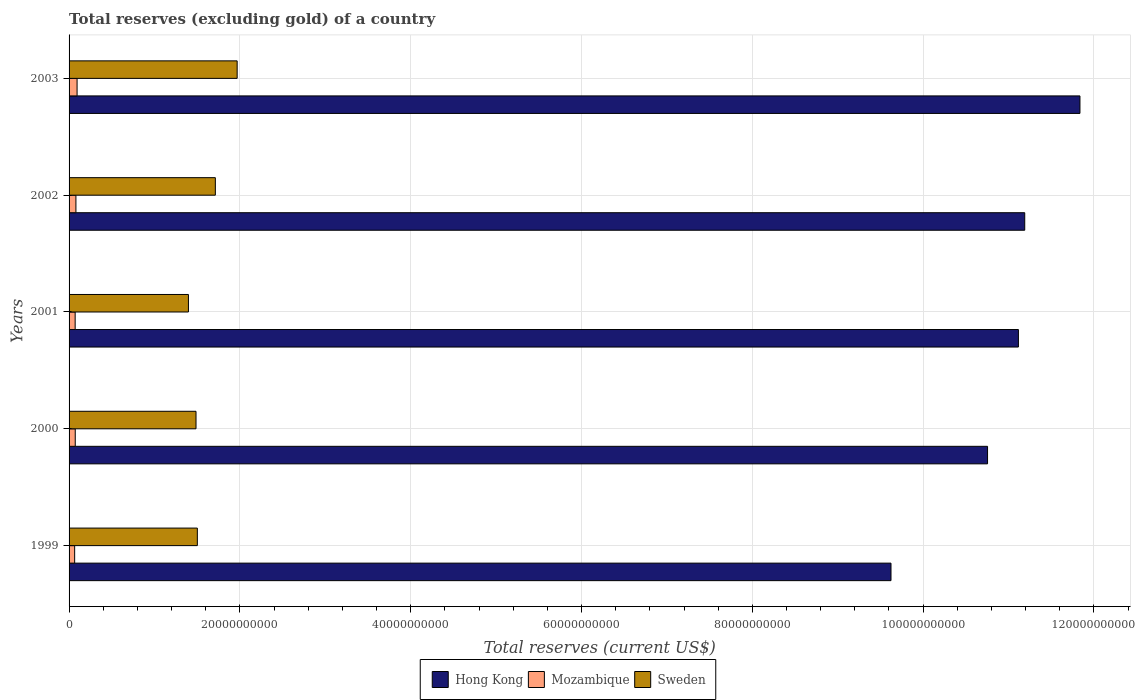How many groups of bars are there?
Offer a very short reply. 5. Are the number of bars per tick equal to the number of legend labels?
Give a very brief answer. Yes. Are the number of bars on each tick of the Y-axis equal?
Provide a short and direct response. Yes. What is the label of the 2nd group of bars from the top?
Your response must be concise. 2002. In how many cases, is the number of bars for a given year not equal to the number of legend labels?
Provide a succinct answer. 0. What is the total reserves (excluding gold) in Mozambique in 2002?
Keep it short and to the point. 8.02e+08. Across all years, what is the maximum total reserves (excluding gold) in Hong Kong?
Provide a succinct answer. 1.18e+11. Across all years, what is the minimum total reserves (excluding gold) in Mozambique?
Ensure brevity in your answer.  6.54e+08. In which year was the total reserves (excluding gold) in Mozambique minimum?
Provide a short and direct response. 1999. What is the total total reserves (excluding gold) in Sweden in the graph?
Your response must be concise. 8.07e+1. What is the difference between the total reserves (excluding gold) in Mozambique in 2000 and that in 2003?
Give a very brief answer. -2.14e+08. What is the difference between the total reserves (excluding gold) in Mozambique in 2001 and the total reserves (excluding gold) in Hong Kong in 2003?
Your answer should be compact. -1.18e+11. What is the average total reserves (excluding gold) in Hong Kong per year?
Make the answer very short. 1.09e+11. In the year 1999, what is the difference between the total reserves (excluding gold) in Mozambique and total reserves (excluding gold) in Hong Kong?
Your response must be concise. -9.56e+1. What is the ratio of the total reserves (excluding gold) in Mozambique in 2001 to that in 2002?
Make the answer very short. 0.89. Is the total reserves (excluding gold) in Mozambique in 1999 less than that in 2002?
Offer a terse response. Yes. What is the difference between the highest and the second highest total reserves (excluding gold) in Sweden?
Provide a short and direct response. 2.55e+09. What is the difference between the highest and the lowest total reserves (excluding gold) in Mozambique?
Your answer should be compact. 2.83e+08. In how many years, is the total reserves (excluding gold) in Hong Kong greater than the average total reserves (excluding gold) in Hong Kong taken over all years?
Offer a very short reply. 3. Is the sum of the total reserves (excluding gold) in Sweden in 2001 and 2003 greater than the maximum total reserves (excluding gold) in Hong Kong across all years?
Your answer should be very brief. No. What does the 3rd bar from the bottom in 2001 represents?
Make the answer very short. Sweden. Is it the case that in every year, the sum of the total reserves (excluding gold) in Mozambique and total reserves (excluding gold) in Hong Kong is greater than the total reserves (excluding gold) in Sweden?
Ensure brevity in your answer.  Yes. How many bars are there?
Give a very brief answer. 15. Are all the bars in the graph horizontal?
Keep it short and to the point. Yes. Does the graph contain grids?
Keep it short and to the point. Yes. What is the title of the graph?
Keep it short and to the point. Total reserves (excluding gold) of a country. Does "Fiji" appear as one of the legend labels in the graph?
Make the answer very short. No. What is the label or title of the X-axis?
Offer a terse response. Total reserves (current US$). What is the Total reserves (current US$) in Hong Kong in 1999?
Your response must be concise. 9.62e+1. What is the Total reserves (current US$) in Mozambique in 1999?
Your answer should be very brief. 6.54e+08. What is the Total reserves (current US$) of Sweden in 1999?
Keep it short and to the point. 1.50e+1. What is the Total reserves (current US$) in Hong Kong in 2000?
Provide a succinct answer. 1.08e+11. What is the Total reserves (current US$) in Mozambique in 2000?
Your response must be concise. 7.23e+08. What is the Total reserves (current US$) in Sweden in 2000?
Offer a terse response. 1.49e+1. What is the Total reserves (current US$) of Hong Kong in 2001?
Provide a succinct answer. 1.11e+11. What is the Total reserves (current US$) in Mozambique in 2001?
Offer a terse response. 7.13e+08. What is the Total reserves (current US$) in Sweden in 2001?
Give a very brief answer. 1.40e+1. What is the Total reserves (current US$) in Hong Kong in 2002?
Your answer should be compact. 1.12e+11. What is the Total reserves (current US$) of Mozambique in 2002?
Ensure brevity in your answer.  8.02e+08. What is the Total reserves (current US$) in Sweden in 2002?
Offer a terse response. 1.71e+1. What is the Total reserves (current US$) of Hong Kong in 2003?
Your answer should be very brief. 1.18e+11. What is the Total reserves (current US$) in Mozambique in 2003?
Offer a terse response. 9.37e+08. What is the Total reserves (current US$) in Sweden in 2003?
Your answer should be very brief. 1.97e+1. Across all years, what is the maximum Total reserves (current US$) of Hong Kong?
Your answer should be very brief. 1.18e+11. Across all years, what is the maximum Total reserves (current US$) of Mozambique?
Provide a short and direct response. 9.37e+08. Across all years, what is the maximum Total reserves (current US$) of Sweden?
Keep it short and to the point. 1.97e+1. Across all years, what is the minimum Total reserves (current US$) of Hong Kong?
Ensure brevity in your answer.  9.62e+1. Across all years, what is the minimum Total reserves (current US$) in Mozambique?
Your answer should be compact. 6.54e+08. Across all years, what is the minimum Total reserves (current US$) of Sweden?
Make the answer very short. 1.40e+1. What is the total Total reserves (current US$) of Hong Kong in the graph?
Provide a succinct answer. 5.45e+11. What is the total Total reserves (current US$) of Mozambique in the graph?
Make the answer very short. 3.83e+09. What is the total Total reserves (current US$) of Sweden in the graph?
Your answer should be compact. 8.07e+1. What is the difference between the Total reserves (current US$) in Hong Kong in 1999 and that in 2000?
Give a very brief answer. -1.13e+1. What is the difference between the Total reserves (current US$) in Mozambique in 1999 and that in 2000?
Your answer should be very brief. -6.92e+07. What is the difference between the Total reserves (current US$) in Sweden in 1999 and that in 2000?
Your answer should be very brief. 1.56e+08. What is the difference between the Total reserves (current US$) of Hong Kong in 1999 and that in 2001?
Your answer should be compact. -1.49e+1. What is the difference between the Total reserves (current US$) of Mozambique in 1999 and that in 2001?
Provide a short and direct response. -5.92e+07. What is the difference between the Total reserves (current US$) of Sweden in 1999 and that in 2001?
Your answer should be very brief. 1.04e+09. What is the difference between the Total reserves (current US$) of Hong Kong in 1999 and that in 2002?
Your answer should be very brief. -1.57e+1. What is the difference between the Total reserves (current US$) of Mozambique in 1999 and that in 2002?
Your answer should be compact. -1.48e+08. What is the difference between the Total reserves (current US$) of Sweden in 1999 and that in 2002?
Your answer should be very brief. -2.11e+09. What is the difference between the Total reserves (current US$) of Hong Kong in 1999 and that in 2003?
Make the answer very short. -2.21e+1. What is the difference between the Total reserves (current US$) of Mozambique in 1999 and that in 2003?
Provide a succinct answer. -2.83e+08. What is the difference between the Total reserves (current US$) in Sweden in 1999 and that in 2003?
Make the answer very short. -4.66e+09. What is the difference between the Total reserves (current US$) of Hong Kong in 2000 and that in 2001?
Offer a very short reply. -3.61e+09. What is the difference between the Total reserves (current US$) of Mozambique in 2000 and that in 2001?
Give a very brief answer. 9.96e+06. What is the difference between the Total reserves (current US$) of Sweden in 2000 and that in 2001?
Provide a succinct answer. 8.86e+08. What is the difference between the Total reserves (current US$) in Hong Kong in 2000 and that in 2002?
Give a very brief answer. -4.35e+09. What is the difference between the Total reserves (current US$) in Mozambique in 2000 and that in 2002?
Keep it short and to the point. -7.93e+07. What is the difference between the Total reserves (current US$) of Sweden in 2000 and that in 2002?
Provide a succinct answer. -2.26e+09. What is the difference between the Total reserves (current US$) of Hong Kong in 2000 and that in 2003?
Make the answer very short. -1.08e+1. What is the difference between the Total reserves (current US$) of Mozambique in 2000 and that in 2003?
Give a very brief answer. -2.14e+08. What is the difference between the Total reserves (current US$) in Sweden in 2000 and that in 2003?
Your answer should be very brief. -4.82e+09. What is the difference between the Total reserves (current US$) of Hong Kong in 2001 and that in 2002?
Make the answer very short. -7.41e+08. What is the difference between the Total reserves (current US$) of Mozambique in 2001 and that in 2002?
Give a very brief answer. -8.93e+07. What is the difference between the Total reserves (current US$) in Sweden in 2001 and that in 2002?
Offer a very short reply. -3.15e+09. What is the difference between the Total reserves (current US$) of Hong Kong in 2001 and that in 2003?
Your answer should be compact. -7.21e+09. What is the difference between the Total reserves (current US$) of Mozambique in 2001 and that in 2003?
Offer a terse response. -2.24e+08. What is the difference between the Total reserves (current US$) in Sweden in 2001 and that in 2003?
Provide a short and direct response. -5.70e+09. What is the difference between the Total reserves (current US$) of Hong Kong in 2002 and that in 2003?
Your answer should be compact. -6.46e+09. What is the difference between the Total reserves (current US$) of Mozambique in 2002 and that in 2003?
Keep it short and to the point. -1.35e+08. What is the difference between the Total reserves (current US$) of Sweden in 2002 and that in 2003?
Provide a succinct answer. -2.55e+09. What is the difference between the Total reserves (current US$) in Hong Kong in 1999 and the Total reserves (current US$) in Mozambique in 2000?
Provide a short and direct response. 9.55e+1. What is the difference between the Total reserves (current US$) in Hong Kong in 1999 and the Total reserves (current US$) in Sweden in 2000?
Offer a very short reply. 8.14e+1. What is the difference between the Total reserves (current US$) in Mozambique in 1999 and the Total reserves (current US$) in Sweden in 2000?
Ensure brevity in your answer.  -1.42e+1. What is the difference between the Total reserves (current US$) in Hong Kong in 1999 and the Total reserves (current US$) in Mozambique in 2001?
Keep it short and to the point. 9.55e+1. What is the difference between the Total reserves (current US$) of Hong Kong in 1999 and the Total reserves (current US$) of Sweden in 2001?
Give a very brief answer. 8.23e+1. What is the difference between the Total reserves (current US$) of Mozambique in 1999 and the Total reserves (current US$) of Sweden in 2001?
Keep it short and to the point. -1.33e+1. What is the difference between the Total reserves (current US$) of Hong Kong in 1999 and the Total reserves (current US$) of Mozambique in 2002?
Your response must be concise. 9.54e+1. What is the difference between the Total reserves (current US$) in Hong Kong in 1999 and the Total reserves (current US$) in Sweden in 2002?
Make the answer very short. 7.91e+1. What is the difference between the Total reserves (current US$) in Mozambique in 1999 and the Total reserves (current US$) in Sweden in 2002?
Keep it short and to the point. -1.65e+1. What is the difference between the Total reserves (current US$) of Hong Kong in 1999 and the Total reserves (current US$) of Mozambique in 2003?
Give a very brief answer. 9.53e+1. What is the difference between the Total reserves (current US$) of Hong Kong in 1999 and the Total reserves (current US$) of Sweden in 2003?
Make the answer very short. 7.66e+1. What is the difference between the Total reserves (current US$) of Mozambique in 1999 and the Total reserves (current US$) of Sweden in 2003?
Provide a succinct answer. -1.90e+1. What is the difference between the Total reserves (current US$) in Hong Kong in 2000 and the Total reserves (current US$) in Mozambique in 2001?
Give a very brief answer. 1.07e+11. What is the difference between the Total reserves (current US$) of Hong Kong in 2000 and the Total reserves (current US$) of Sweden in 2001?
Your answer should be compact. 9.36e+1. What is the difference between the Total reserves (current US$) of Mozambique in 2000 and the Total reserves (current US$) of Sweden in 2001?
Your answer should be compact. -1.33e+1. What is the difference between the Total reserves (current US$) of Hong Kong in 2000 and the Total reserves (current US$) of Mozambique in 2002?
Your response must be concise. 1.07e+11. What is the difference between the Total reserves (current US$) of Hong Kong in 2000 and the Total reserves (current US$) of Sweden in 2002?
Make the answer very short. 9.04e+1. What is the difference between the Total reserves (current US$) of Mozambique in 2000 and the Total reserves (current US$) of Sweden in 2002?
Provide a succinct answer. -1.64e+1. What is the difference between the Total reserves (current US$) of Hong Kong in 2000 and the Total reserves (current US$) of Mozambique in 2003?
Your answer should be very brief. 1.07e+11. What is the difference between the Total reserves (current US$) in Hong Kong in 2000 and the Total reserves (current US$) in Sweden in 2003?
Provide a short and direct response. 8.79e+1. What is the difference between the Total reserves (current US$) in Mozambique in 2000 and the Total reserves (current US$) in Sweden in 2003?
Offer a terse response. -1.90e+1. What is the difference between the Total reserves (current US$) of Hong Kong in 2001 and the Total reserves (current US$) of Mozambique in 2002?
Provide a short and direct response. 1.10e+11. What is the difference between the Total reserves (current US$) in Hong Kong in 2001 and the Total reserves (current US$) in Sweden in 2002?
Your answer should be compact. 9.40e+1. What is the difference between the Total reserves (current US$) of Mozambique in 2001 and the Total reserves (current US$) of Sweden in 2002?
Your answer should be very brief. -1.64e+1. What is the difference between the Total reserves (current US$) of Hong Kong in 2001 and the Total reserves (current US$) of Mozambique in 2003?
Offer a very short reply. 1.10e+11. What is the difference between the Total reserves (current US$) of Hong Kong in 2001 and the Total reserves (current US$) of Sweden in 2003?
Offer a terse response. 9.15e+1. What is the difference between the Total reserves (current US$) of Mozambique in 2001 and the Total reserves (current US$) of Sweden in 2003?
Keep it short and to the point. -1.90e+1. What is the difference between the Total reserves (current US$) of Hong Kong in 2002 and the Total reserves (current US$) of Mozambique in 2003?
Your response must be concise. 1.11e+11. What is the difference between the Total reserves (current US$) in Hong Kong in 2002 and the Total reserves (current US$) in Sweden in 2003?
Your answer should be compact. 9.22e+1. What is the difference between the Total reserves (current US$) of Mozambique in 2002 and the Total reserves (current US$) of Sweden in 2003?
Your answer should be very brief. -1.89e+1. What is the average Total reserves (current US$) of Hong Kong per year?
Make the answer very short. 1.09e+11. What is the average Total reserves (current US$) of Mozambique per year?
Make the answer very short. 7.66e+08. What is the average Total reserves (current US$) of Sweden per year?
Offer a very short reply. 1.61e+1. In the year 1999, what is the difference between the Total reserves (current US$) of Hong Kong and Total reserves (current US$) of Mozambique?
Provide a succinct answer. 9.56e+1. In the year 1999, what is the difference between the Total reserves (current US$) in Hong Kong and Total reserves (current US$) in Sweden?
Your answer should be very brief. 8.12e+1. In the year 1999, what is the difference between the Total reserves (current US$) of Mozambique and Total reserves (current US$) of Sweden?
Provide a succinct answer. -1.44e+1. In the year 2000, what is the difference between the Total reserves (current US$) of Hong Kong and Total reserves (current US$) of Mozambique?
Offer a very short reply. 1.07e+11. In the year 2000, what is the difference between the Total reserves (current US$) in Hong Kong and Total reserves (current US$) in Sweden?
Ensure brevity in your answer.  9.27e+1. In the year 2000, what is the difference between the Total reserves (current US$) of Mozambique and Total reserves (current US$) of Sweden?
Give a very brief answer. -1.41e+1. In the year 2001, what is the difference between the Total reserves (current US$) in Hong Kong and Total reserves (current US$) in Mozambique?
Offer a very short reply. 1.10e+11. In the year 2001, what is the difference between the Total reserves (current US$) of Hong Kong and Total reserves (current US$) of Sweden?
Your response must be concise. 9.72e+1. In the year 2001, what is the difference between the Total reserves (current US$) in Mozambique and Total reserves (current US$) in Sweden?
Offer a terse response. -1.33e+1. In the year 2002, what is the difference between the Total reserves (current US$) of Hong Kong and Total reserves (current US$) of Mozambique?
Ensure brevity in your answer.  1.11e+11. In the year 2002, what is the difference between the Total reserves (current US$) of Hong Kong and Total reserves (current US$) of Sweden?
Make the answer very short. 9.48e+1. In the year 2002, what is the difference between the Total reserves (current US$) in Mozambique and Total reserves (current US$) in Sweden?
Offer a very short reply. -1.63e+1. In the year 2003, what is the difference between the Total reserves (current US$) of Hong Kong and Total reserves (current US$) of Mozambique?
Ensure brevity in your answer.  1.17e+11. In the year 2003, what is the difference between the Total reserves (current US$) in Hong Kong and Total reserves (current US$) in Sweden?
Provide a short and direct response. 9.87e+1. In the year 2003, what is the difference between the Total reserves (current US$) of Mozambique and Total reserves (current US$) of Sweden?
Your response must be concise. -1.87e+1. What is the ratio of the Total reserves (current US$) of Hong Kong in 1999 to that in 2000?
Offer a terse response. 0.89. What is the ratio of the Total reserves (current US$) of Mozambique in 1999 to that in 2000?
Ensure brevity in your answer.  0.9. What is the ratio of the Total reserves (current US$) of Sweden in 1999 to that in 2000?
Give a very brief answer. 1.01. What is the ratio of the Total reserves (current US$) in Hong Kong in 1999 to that in 2001?
Your answer should be compact. 0.87. What is the ratio of the Total reserves (current US$) in Mozambique in 1999 to that in 2001?
Make the answer very short. 0.92. What is the ratio of the Total reserves (current US$) in Sweden in 1999 to that in 2001?
Your answer should be very brief. 1.07. What is the ratio of the Total reserves (current US$) in Hong Kong in 1999 to that in 2002?
Make the answer very short. 0.86. What is the ratio of the Total reserves (current US$) in Mozambique in 1999 to that in 2002?
Your answer should be very brief. 0.81. What is the ratio of the Total reserves (current US$) in Sweden in 1999 to that in 2002?
Keep it short and to the point. 0.88. What is the ratio of the Total reserves (current US$) in Hong Kong in 1999 to that in 2003?
Your response must be concise. 0.81. What is the ratio of the Total reserves (current US$) of Mozambique in 1999 to that in 2003?
Provide a short and direct response. 0.7. What is the ratio of the Total reserves (current US$) of Sweden in 1999 to that in 2003?
Your answer should be compact. 0.76. What is the ratio of the Total reserves (current US$) of Hong Kong in 2000 to that in 2001?
Provide a succinct answer. 0.97. What is the ratio of the Total reserves (current US$) of Sweden in 2000 to that in 2001?
Provide a succinct answer. 1.06. What is the ratio of the Total reserves (current US$) in Hong Kong in 2000 to that in 2002?
Offer a terse response. 0.96. What is the ratio of the Total reserves (current US$) of Mozambique in 2000 to that in 2002?
Offer a very short reply. 0.9. What is the ratio of the Total reserves (current US$) of Sweden in 2000 to that in 2002?
Provide a short and direct response. 0.87. What is the ratio of the Total reserves (current US$) of Hong Kong in 2000 to that in 2003?
Offer a terse response. 0.91. What is the ratio of the Total reserves (current US$) of Mozambique in 2000 to that in 2003?
Give a very brief answer. 0.77. What is the ratio of the Total reserves (current US$) in Sweden in 2000 to that in 2003?
Ensure brevity in your answer.  0.76. What is the ratio of the Total reserves (current US$) in Hong Kong in 2001 to that in 2002?
Your answer should be very brief. 0.99. What is the ratio of the Total reserves (current US$) of Mozambique in 2001 to that in 2002?
Make the answer very short. 0.89. What is the ratio of the Total reserves (current US$) of Sweden in 2001 to that in 2002?
Provide a short and direct response. 0.82. What is the ratio of the Total reserves (current US$) in Hong Kong in 2001 to that in 2003?
Your answer should be compact. 0.94. What is the ratio of the Total reserves (current US$) in Mozambique in 2001 to that in 2003?
Offer a very short reply. 0.76. What is the ratio of the Total reserves (current US$) of Sweden in 2001 to that in 2003?
Offer a very short reply. 0.71. What is the ratio of the Total reserves (current US$) of Hong Kong in 2002 to that in 2003?
Provide a succinct answer. 0.95. What is the ratio of the Total reserves (current US$) of Mozambique in 2002 to that in 2003?
Make the answer very short. 0.86. What is the ratio of the Total reserves (current US$) in Sweden in 2002 to that in 2003?
Make the answer very short. 0.87. What is the difference between the highest and the second highest Total reserves (current US$) of Hong Kong?
Offer a terse response. 6.46e+09. What is the difference between the highest and the second highest Total reserves (current US$) of Mozambique?
Your answer should be compact. 1.35e+08. What is the difference between the highest and the second highest Total reserves (current US$) of Sweden?
Your answer should be very brief. 2.55e+09. What is the difference between the highest and the lowest Total reserves (current US$) of Hong Kong?
Give a very brief answer. 2.21e+1. What is the difference between the highest and the lowest Total reserves (current US$) in Mozambique?
Offer a very short reply. 2.83e+08. What is the difference between the highest and the lowest Total reserves (current US$) in Sweden?
Make the answer very short. 5.70e+09. 